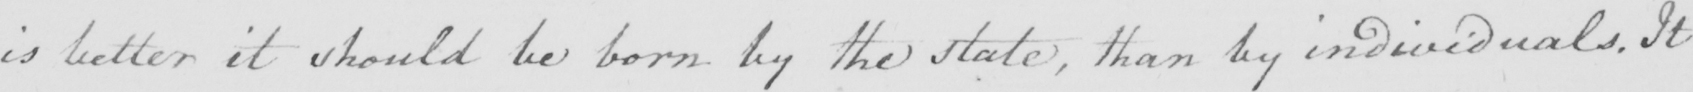What text is written in this handwritten line? is better it should be born by the state , than by individuals . It 